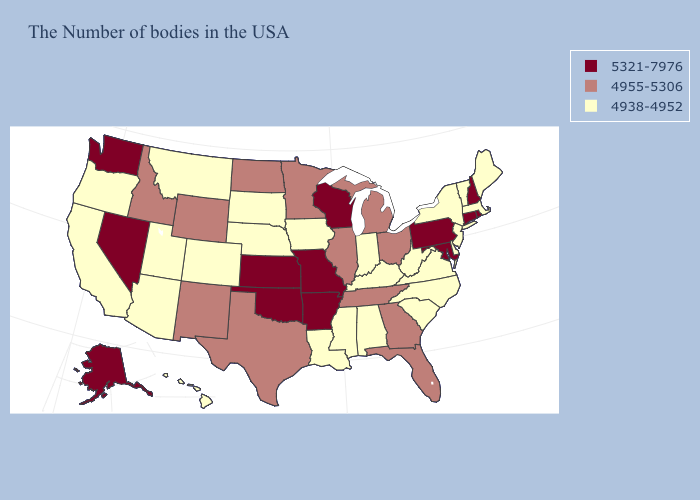Does Hawaii have a lower value than California?
Short answer required. No. How many symbols are there in the legend?
Keep it brief. 3. What is the value of Tennessee?
Give a very brief answer. 4955-5306. Does New York have the lowest value in the USA?
Short answer required. Yes. Which states have the highest value in the USA?
Concise answer only. Rhode Island, New Hampshire, Connecticut, Maryland, Pennsylvania, Wisconsin, Missouri, Arkansas, Kansas, Oklahoma, Nevada, Washington, Alaska. Does Mississippi have a lower value than Vermont?
Give a very brief answer. No. What is the value of Nebraska?
Short answer required. 4938-4952. Name the states that have a value in the range 4938-4952?
Short answer required. Maine, Massachusetts, Vermont, New York, New Jersey, Delaware, Virginia, North Carolina, South Carolina, West Virginia, Kentucky, Indiana, Alabama, Mississippi, Louisiana, Iowa, Nebraska, South Dakota, Colorado, Utah, Montana, Arizona, California, Oregon, Hawaii. Does Wyoming have the highest value in the West?
Short answer required. No. Name the states that have a value in the range 5321-7976?
Answer briefly. Rhode Island, New Hampshire, Connecticut, Maryland, Pennsylvania, Wisconsin, Missouri, Arkansas, Kansas, Oklahoma, Nevada, Washington, Alaska. What is the value of New Mexico?
Short answer required. 4955-5306. What is the lowest value in states that border Montana?
Write a very short answer. 4938-4952. Does Rhode Island have the highest value in the Northeast?
Answer briefly. Yes. Which states have the lowest value in the Northeast?
Quick response, please. Maine, Massachusetts, Vermont, New York, New Jersey. Name the states that have a value in the range 4955-5306?
Be succinct. Ohio, Florida, Georgia, Michigan, Tennessee, Illinois, Minnesota, Texas, North Dakota, Wyoming, New Mexico, Idaho. 